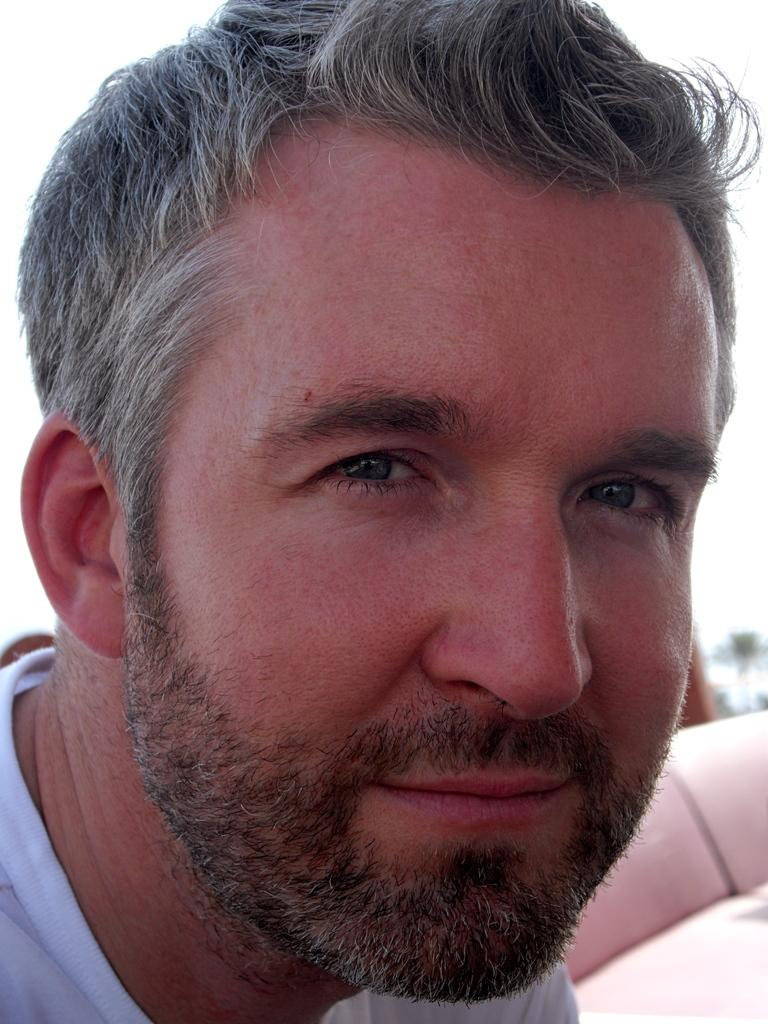What is the main subject of the image? There is a face of a person in the image. What does the person in the image look interested in? There is no information provided about the person's interests or what they might be looking at in the image. --- Facts: 1. There is a car in the image. 2. The car is red. 3. The car has four wheels. 4. The car has a license plate. 5. The car is parked on the street. Absurd Topics: fly, swim, bark Conversation: What is the color of the car in the image? The car is red. How many wheels does the car have? The car has four wheels. Does the car have any identifying features? Yes, the car has a license plate. Where is the car located in the image? The car is parked on the street. Reasoning: Let's think step by step in order to produce the conversation. We start by identifying the main subject of the image, which is the car. Then, we expand the conversation to include other details about the car, such as its color, number of wheels, and the presence of a license plate. Finally, we describe the car's location in the image, which is parked on the street. Each question is designed to elicit a specific detail about the image that is known from the provided facts. Absurd Question/Answer: Can the car in the image swim across a river? Cars are not capable of swimming, so the car in the image cannot swim across a river. 